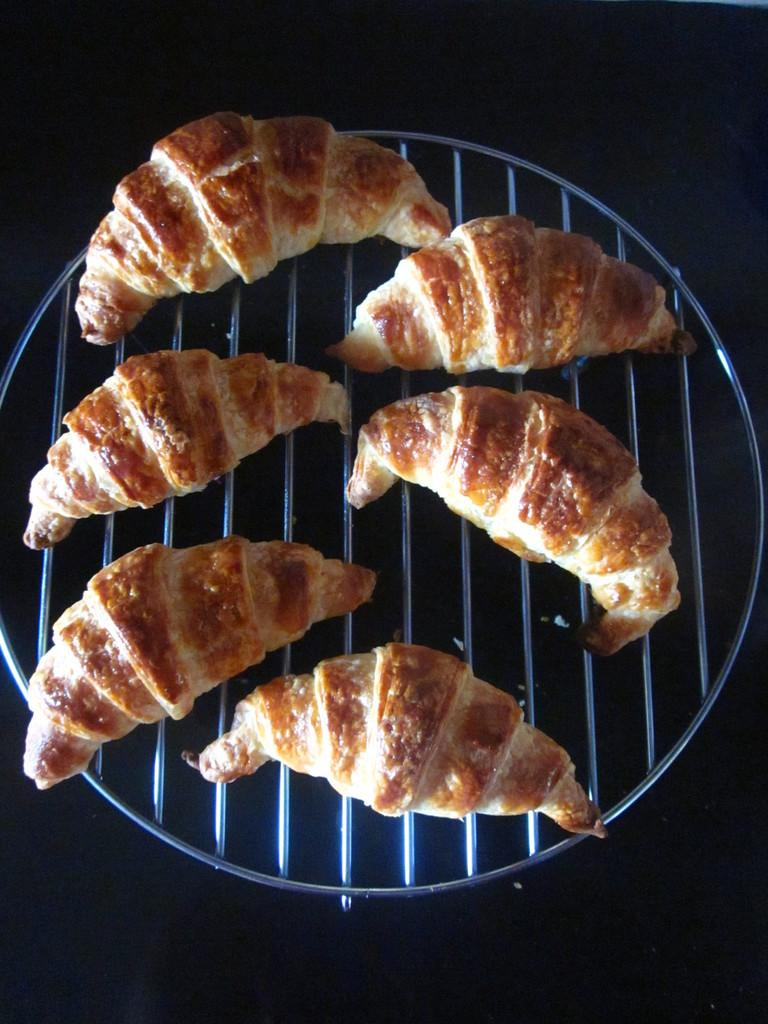What is being cooked on the barbecue grill in the image? There is food on the barbecue grill in the image. What can be seen in the background of the image? The background of the image is black. How many socks are hanging on the clothesline in the image? There is no clothesline or socks present in the image. What advice might the grandfather give to the person cooking the food in the image? There is no grandfather present in the image, so it is not possible to determine what advice he might give. 